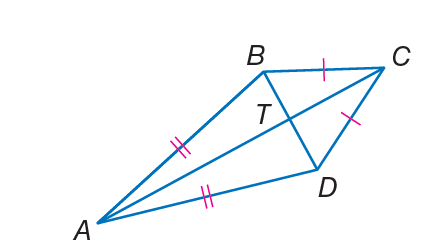Question: If B T = 5 and T C = 8, find C D.
Choices:
A. \sqrt { 89 }
B. 25
C. 35
D. 64
Answer with the letter. Answer: A Question: If m \angle B A D = 38 and m \angle B C D = 50, find m \angle A D C.
Choices:
A. 12
B. 34
C. 56
D. 146
Answer with the letter. Answer: D 